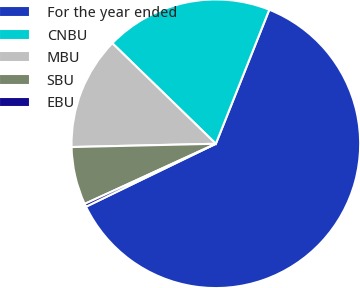Convert chart. <chart><loc_0><loc_0><loc_500><loc_500><pie_chart><fcel>For the year ended<fcel>CNBU<fcel>MBU<fcel>SBU<fcel>EBU<nl><fcel>61.78%<fcel>18.77%<fcel>12.63%<fcel>6.48%<fcel>0.34%<nl></chart> 